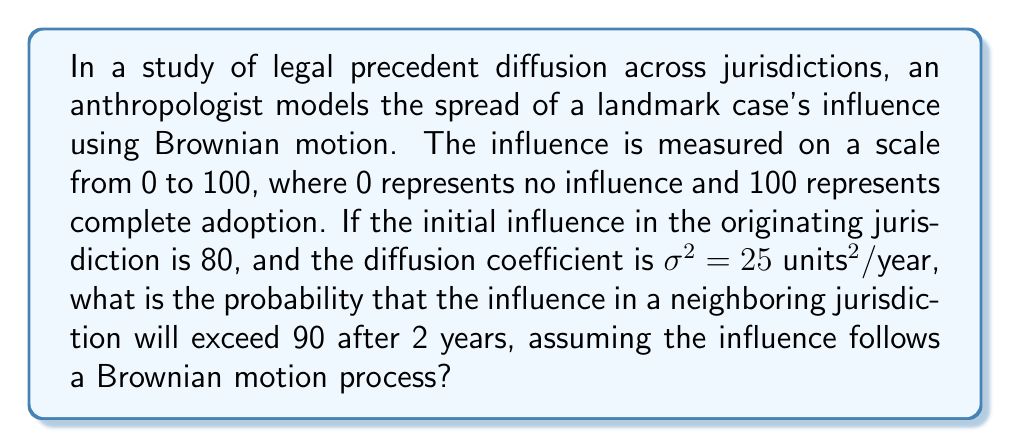What is the answer to this math problem? To solve this problem, we'll use the properties of Brownian motion and the normal distribution:

1) In Brownian motion, the change in position (influence in this case) follows a normal distribution with:
   Mean = 0
   Variance = $\sigma^2 t$, where $t$ is time

2) Given:
   Initial influence: $X_0 = 80$
   Time: $t = 2$ years
   Diffusion coefficient: $\sigma^2 = 25$ units²/year

3) The influence after 2 years, $X_2$, follows a normal distribution:
   $X_2 \sim N(\mu, \sigma^2 t)$
   Where $\mu = X_0 = 80$ (the mean doesn't change in Brownian motion)
   And variance = $25 * 2 = 50$

4) We want to find: $P(X_2 > 90)$

5) Standardize the normal distribution:
   $Z = \frac{X - \mu}{\sqrt{\sigma^2 t}} = \frac{X - 80}{\sqrt{50}}$

6) The probability we're looking for is:
   $P(X_2 > 90) = P(Z > \frac{90 - 80}{\sqrt{50}}) = P(Z > \frac{10}{\sqrt{50}}) = P(Z > \frac{10}{7.071}) = P(Z > 1.414)$

7) Using a standard normal distribution table or calculator:
   $P(Z > 1.414) = 1 - P(Z < 1.414) = 1 - 0.9213 = 0.0787$

Therefore, the probability that the influence will exceed 90 after 2 years is approximately 0.0787 or 7.87%.
Answer: 0.0787 